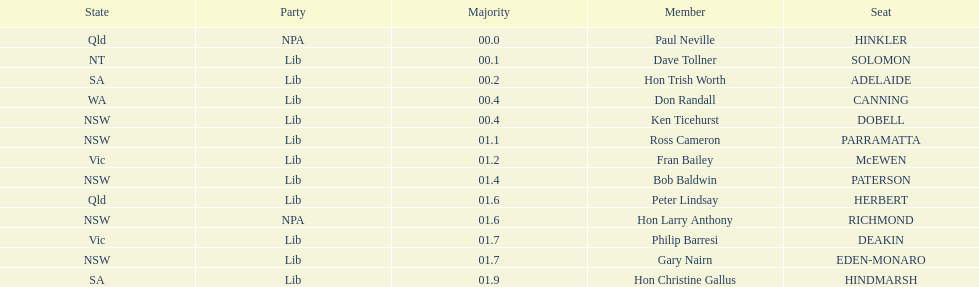What party had the most seats? Lib. 